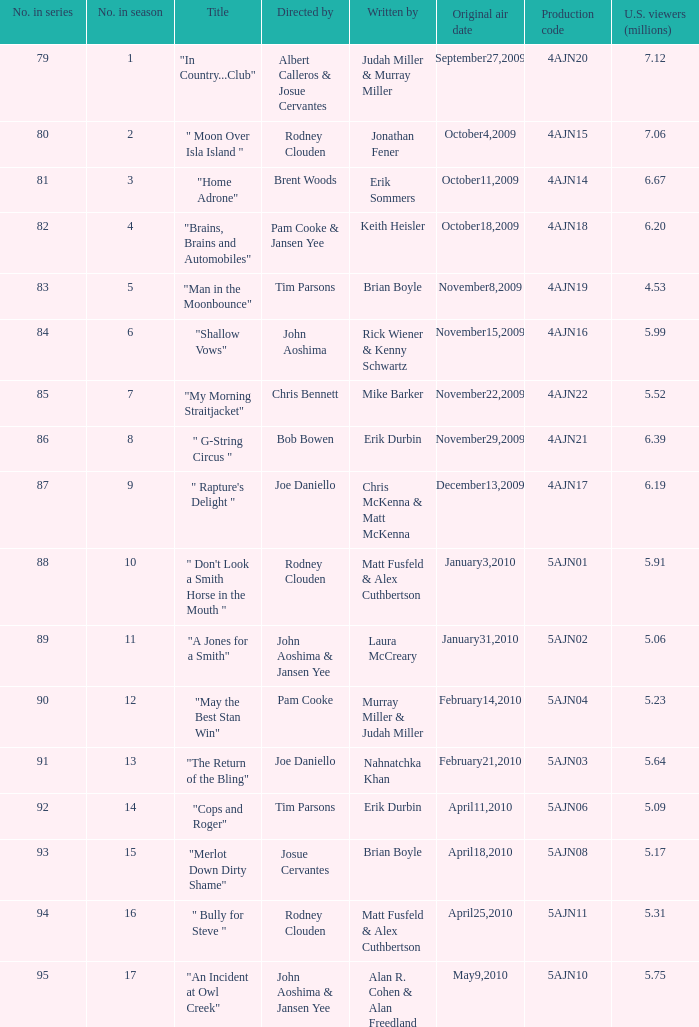Who is the writer of the episode directed by pam cooke & jansen yee? Keith Heisler. 